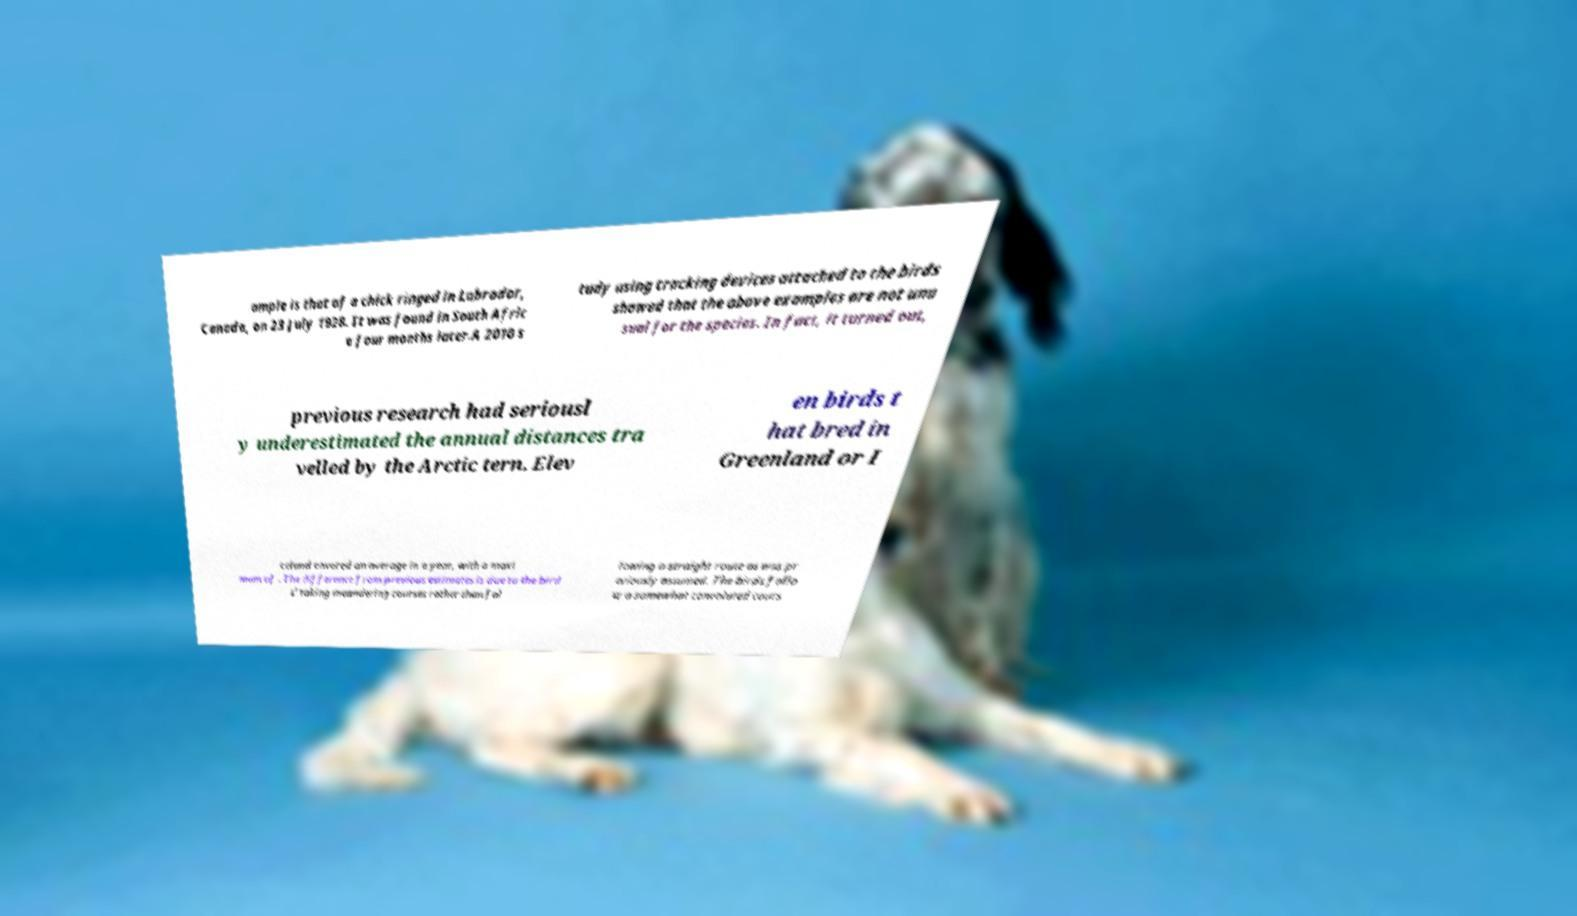I need the written content from this picture converted into text. Can you do that? ample is that of a chick ringed in Labrador, Canada, on 23 July 1928. It was found in South Afric a four months later.A 2010 s tudy using tracking devices attached to the birds showed that the above examples are not unu sual for the species. In fact, it turned out, previous research had seriousl y underestimated the annual distances tra velled by the Arctic tern. Elev en birds t hat bred in Greenland or I celand covered on average in a year, with a maxi mum of . The difference from previous estimates is due to the bird s' taking meandering courses rather than fol lowing a straight route as was pr eviously assumed. The birds follo w a somewhat convoluted cours 